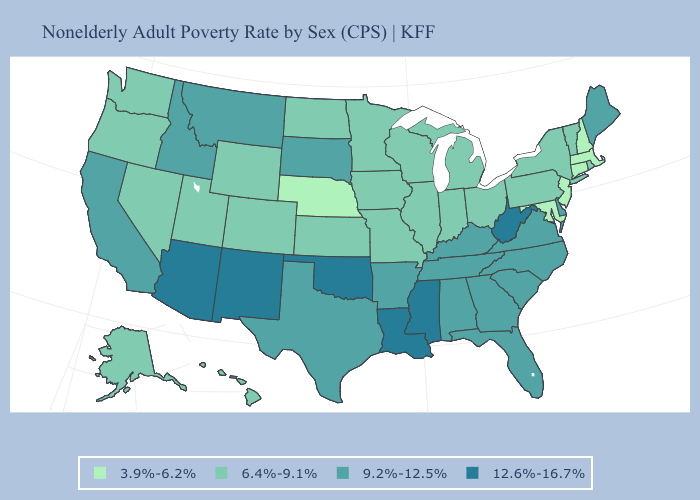Does the first symbol in the legend represent the smallest category?
Short answer required. Yes. Among the states that border Massachusetts , does New Hampshire have the lowest value?
Concise answer only. Yes. Does Arizona have the lowest value in the West?
Quick response, please. No. Does Wyoming have a higher value than Maryland?
Short answer required. Yes. What is the value of Oklahoma?
Concise answer only. 12.6%-16.7%. Does Nebraska have the lowest value in the USA?
Quick response, please. Yes. What is the highest value in states that border New Mexico?
Keep it brief. 12.6%-16.7%. Name the states that have a value in the range 9.2%-12.5%?
Write a very short answer. Alabama, Arkansas, California, Delaware, Florida, Georgia, Idaho, Kentucky, Maine, Montana, North Carolina, South Carolina, South Dakota, Tennessee, Texas, Virginia. Among the states that border Tennessee , does Mississippi have the highest value?
Write a very short answer. Yes. Among the states that border Washington , which have the highest value?
Quick response, please. Idaho. Name the states that have a value in the range 6.4%-9.1%?
Short answer required. Alaska, Colorado, Hawaii, Illinois, Indiana, Iowa, Kansas, Michigan, Minnesota, Missouri, Nevada, New York, North Dakota, Ohio, Oregon, Pennsylvania, Rhode Island, Utah, Vermont, Washington, Wisconsin, Wyoming. Does the map have missing data?
Keep it brief. No. Name the states that have a value in the range 9.2%-12.5%?
Write a very short answer. Alabama, Arkansas, California, Delaware, Florida, Georgia, Idaho, Kentucky, Maine, Montana, North Carolina, South Carolina, South Dakota, Tennessee, Texas, Virginia. Which states have the lowest value in the USA?
Short answer required. Connecticut, Maryland, Massachusetts, Nebraska, New Hampshire, New Jersey. 